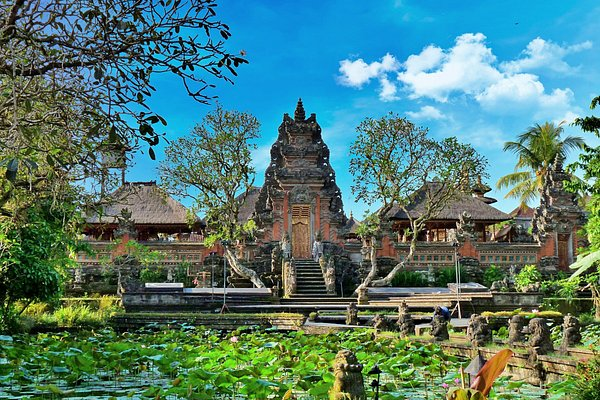What can you tell me about the architectural style of the buildings in the image? The architectural style of the buildings in the image is traditional Balinese. This style is characterized by intricate carvings, multi-tiered roofs, and a harmonious integration with the surrounding natural environment. The structures exhibit a blend of Hindu and Buddhist influences, noticeable in their ornate details and symbolic motifs. The use of natural materials such as wood, stone, and thatch complements the lush tropical surroundings, creating a serene and cohesive aesthetic. 